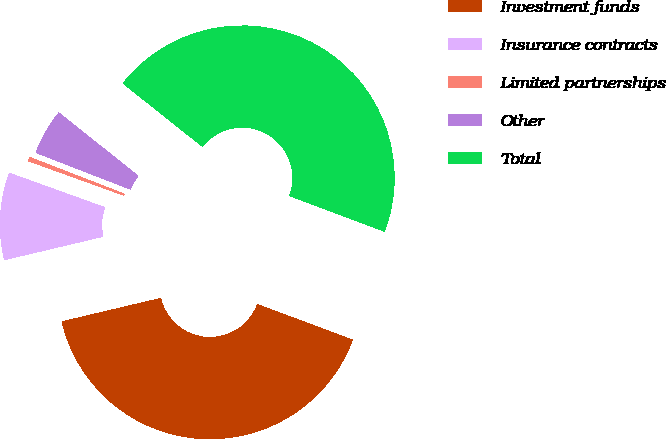Convert chart. <chart><loc_0><loc_0><loc_500><loc_500><pie_chart><fcel>Investment funds<fcel>Insurance contracts<fcel>Limited partnerships<fcel>Other<fcel>Total<nl><fcel>40.6%<fcel>9.2%<fcel>0.39%<fcel>4.8%<fcel>45.01%<nl></chart> 